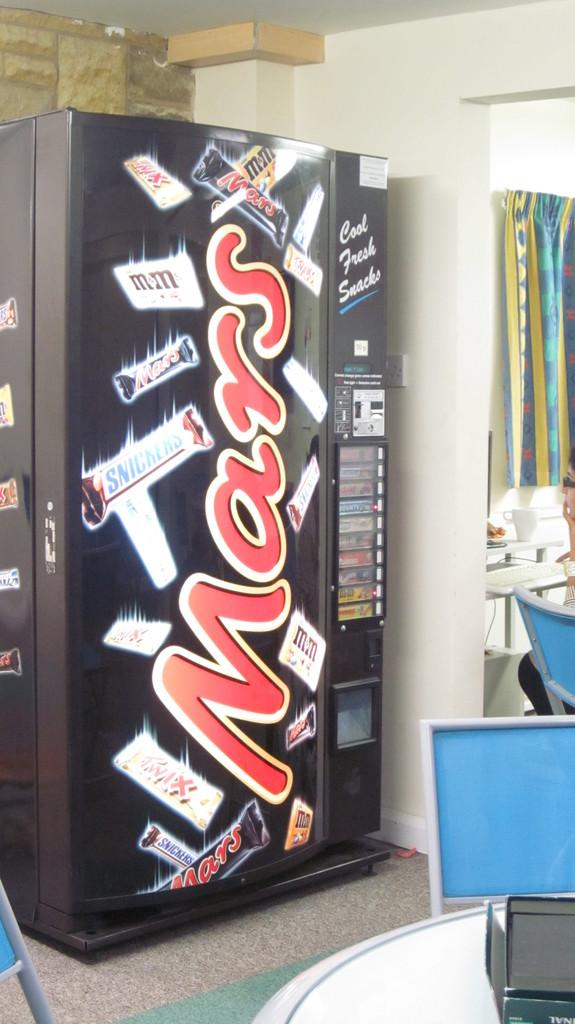<image>
Create a compact narrative representing the image presented. A black vending machine with the word Mars written in red letters. 